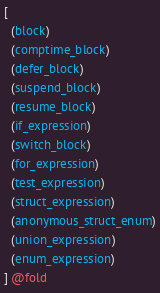<code> <loc_0><loc_0><loc_500><loc_500><_Scheme_>[
  (block)
  (comptime_block)
  (defer_block)
  (suspend_block)
  (resume_block)
  (if_expression)
  (switch_block)
  (for_expression)
  (test_expression)
  (struct_expression)
  (anonymous_struct_enum)
  (union_expression)
  (enum_expression)
] @fold
</code> 